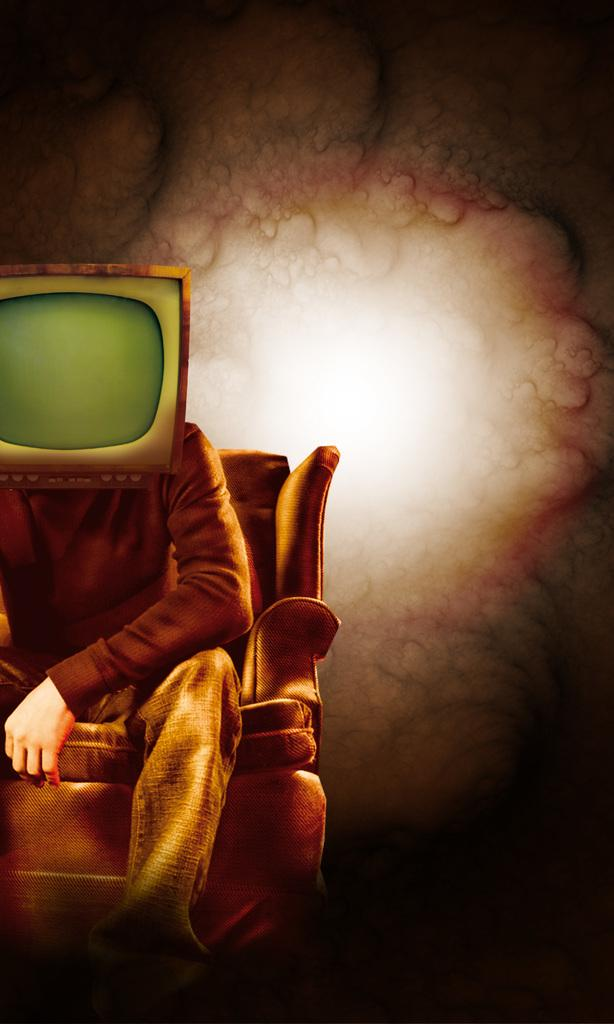Who is present in the image? There is a man in the image. What is the man doing in the image? The man is seated on a chair. What object can be seen in the image besides the man? There is a monitor in the image. What type of steel is the cow made of in the image? There is no cow present in the image, and therefore no such material can be identified. 